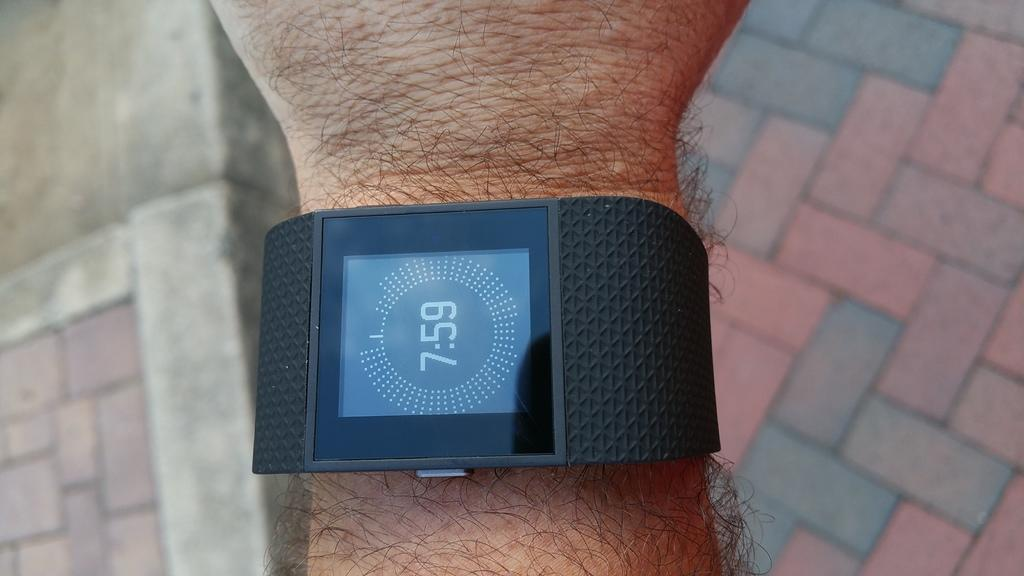Provide a one-sentence caption for the provided image. a clock that has the time of 7:59 on it. 